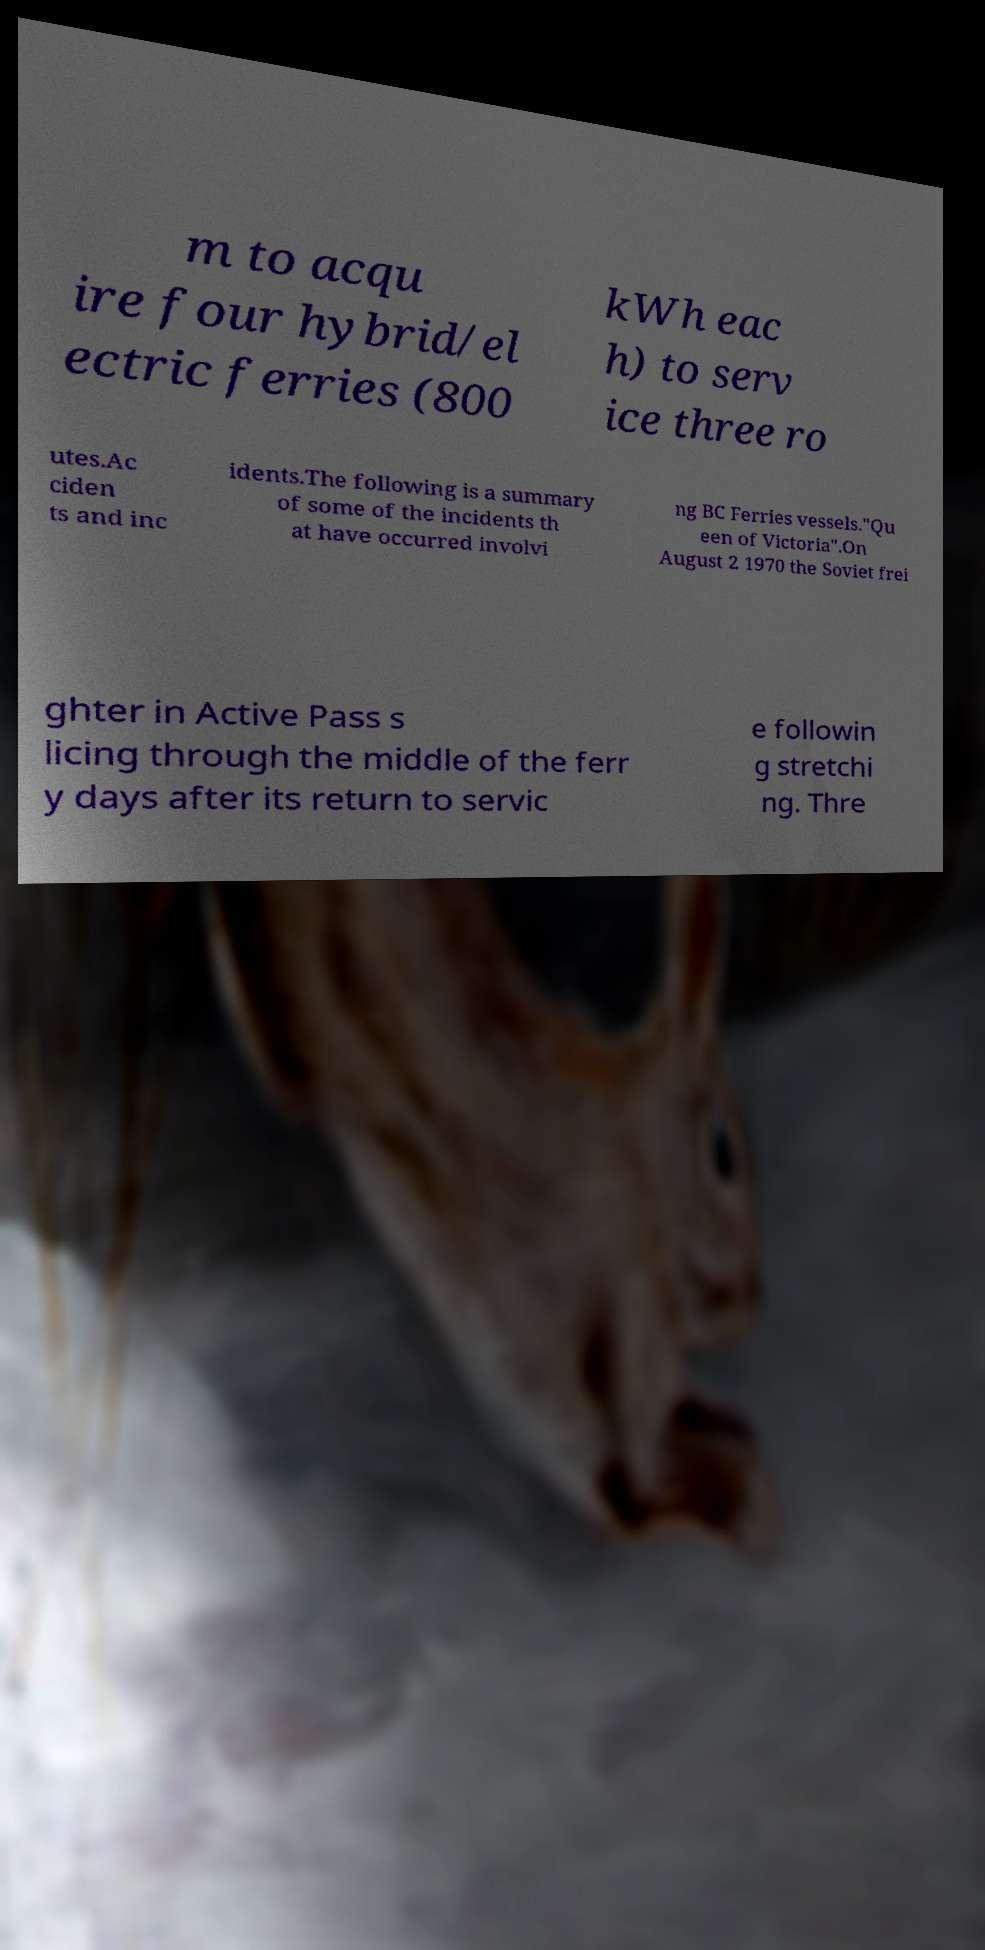Please identify and transcribe the text found in this image. m to acqu ire four hybrid/el ectric ferries (800 kWh eac h) to serv ice three ro utes.Ac ciden ts and inc idents.The following is a summary of some of the incidents th at have occurred involvi ng BC Ferries vessels."Qu een of Victoria".On August 2 1970 the Soviet frei ghter in Active Pass s licing through the middle of the ferr y days after its return to servic e followin g stretchi ng. Thre 